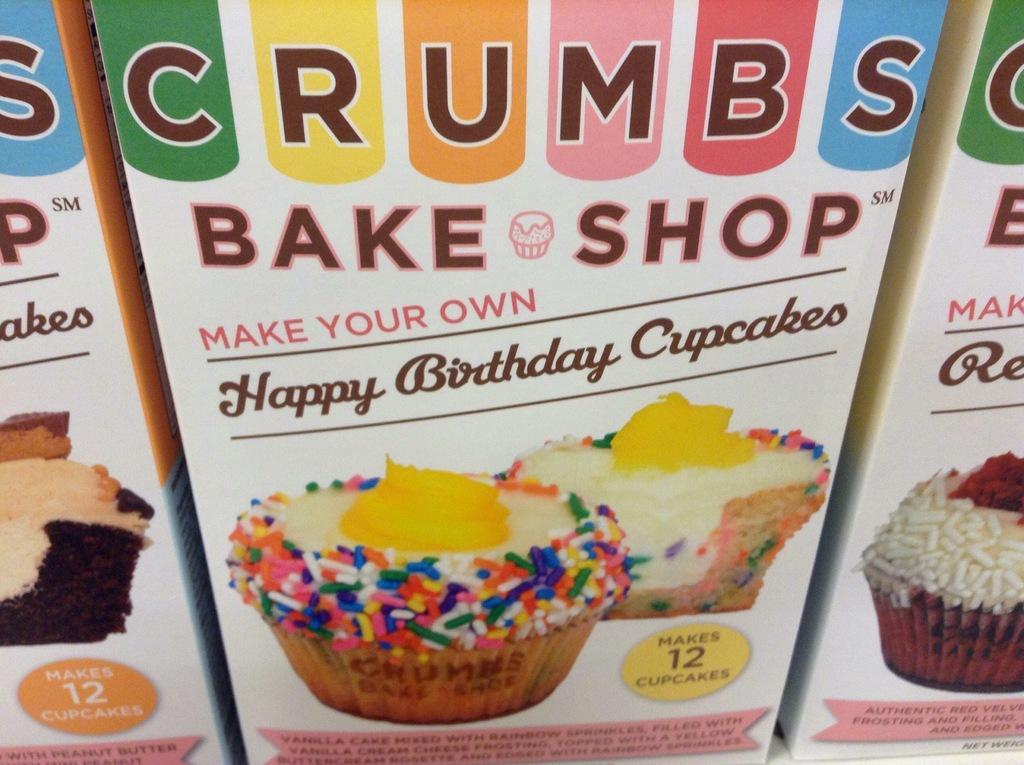Please provide a concise description of this image. In the foreground of this image, there are cupcake boxes and images of cupcakes on it. 